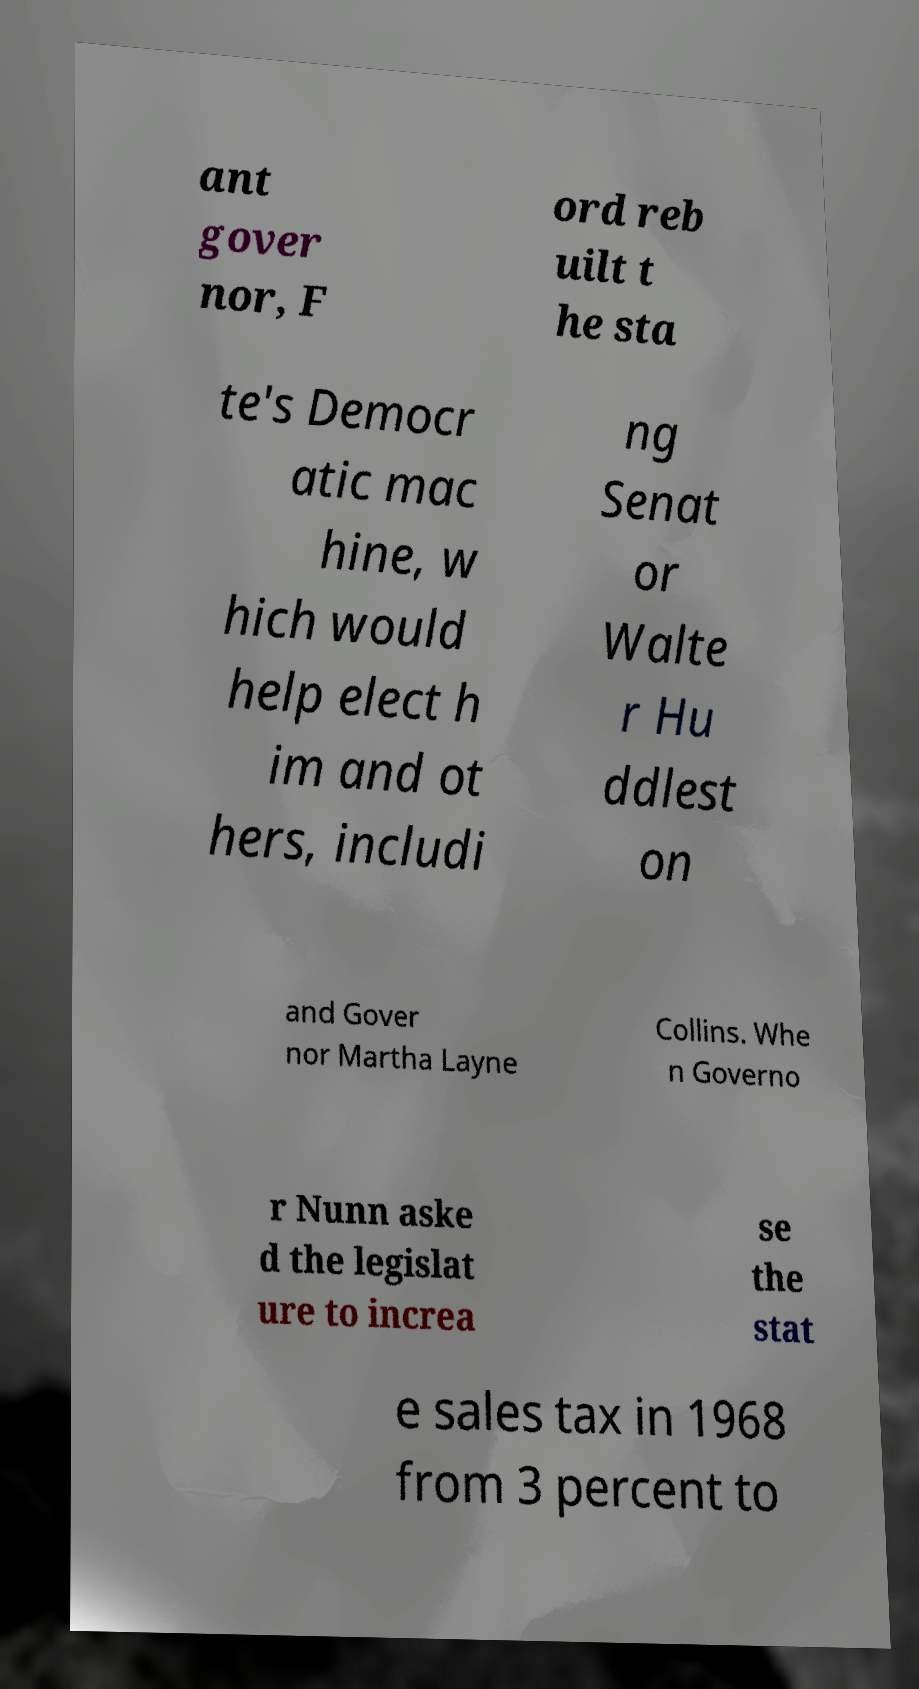Can you read and provide the text displayed in the image?This photo seems to have some interesting text. Can you extract and type it out for me? ant gover nor, F ord reb uilt t he sta te's Democr atic mac hine, w hich would help elect h im and ot hers, includi ng Senat or Walte r Hu ddlest on and Gover nor Martha Layne Collins. Whe n Governo r Nunn aske d the legislat ure to increa se the stat e sales tax in 1968 from 3 percent to 